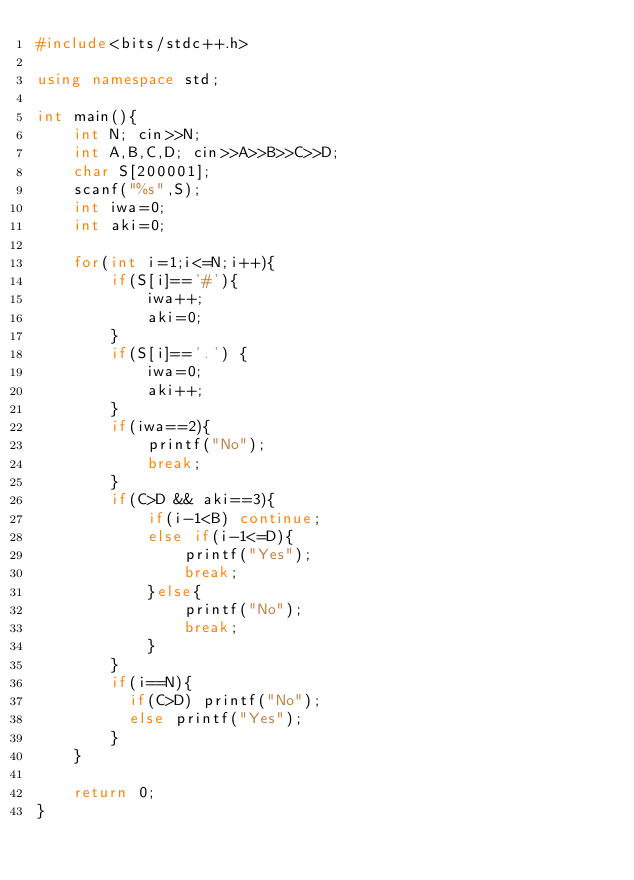<code> <loc_0><loc_0><loc_500><loc_500><_C++_>#include<bits/stdc++.h>

using namespace std;

int main(){
    int N; cin>>N;
    int A,B,C,D; cin>>A>>B>>C>>D;
    char S[200001];
    scanf("%s",S);
    int iwa=0;
    int aki=0;

    for(int i=1;i<=N;i++){
        if(S[i]=='#'){
            iwa++;
            aki=0;
        }
        if(S[i]=='.') {
            iwa=0;
            aki++;
        }
        if(iwa==2){
            printf("No");
            break;
        }
        if(C>D && aki==3){
          	if(i-1<B) continue;
            else if(i-1<=D){
                printf("Yes");
                break;
            }else{
                printf("No");
                break;
            }
        }
      	if(i==N){
        	if(C>D) printf("No");
      		else printf("Yes");
        }
    }

    return 0;
}</code> 